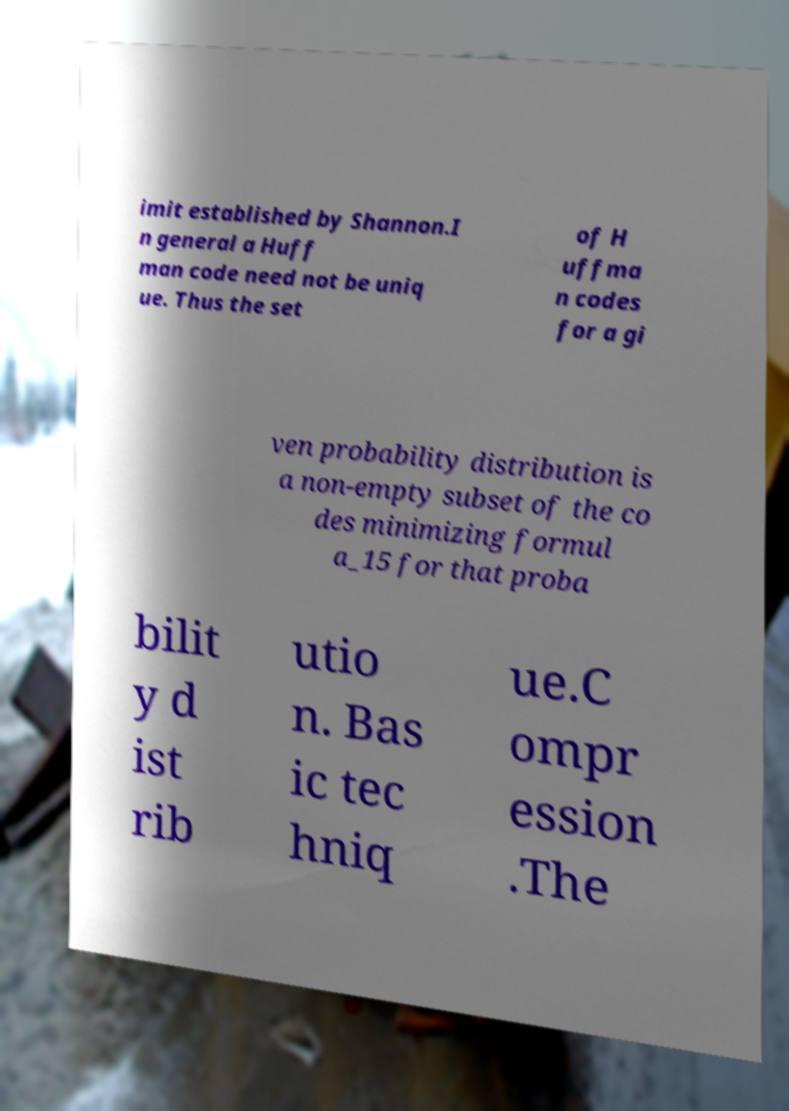Could you extract and type out the text from this image? imit established by Shannon.I n general a Huff man code need not be uniq ue. Thus the set of H uffma n codes for a gi ven probability distribution is a non-empty subset of the co des minimizing formul a_15 for that proba bilit y d ist rib utio n. Bas ic tec hniq ue.C ompr ession .The 